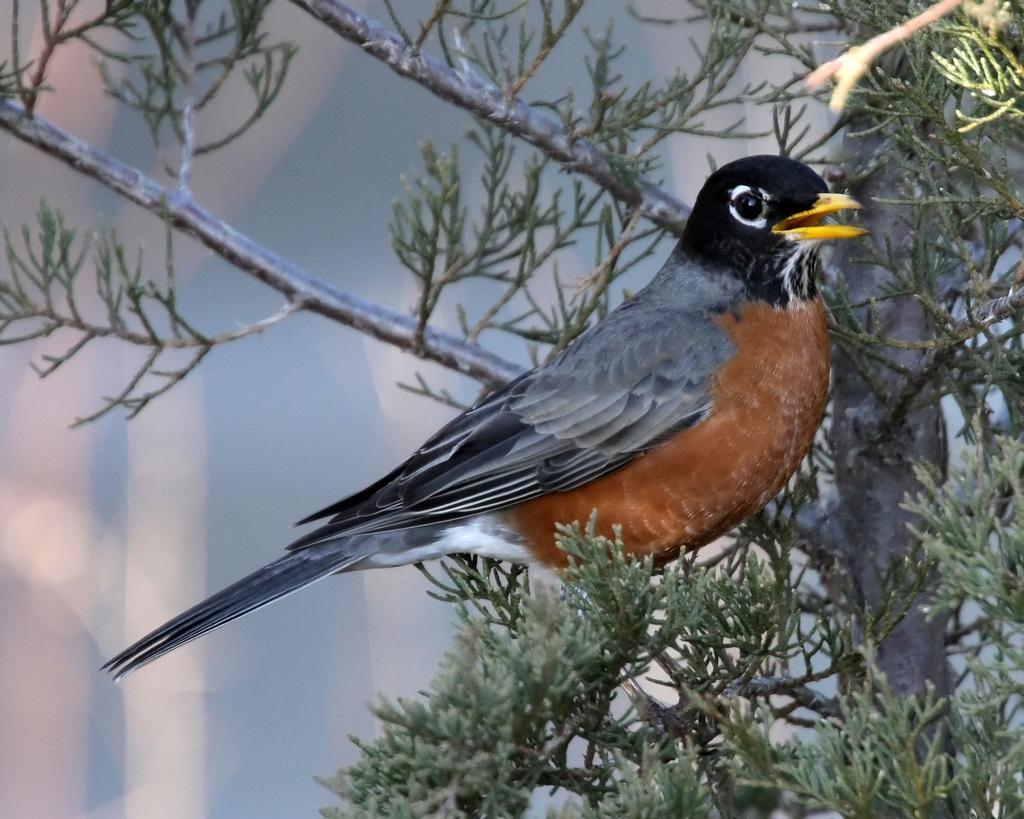Please provide a concise description of this image. In this image there is a bird standing on the branch of the tree. In the background there are leaves and a tree. 